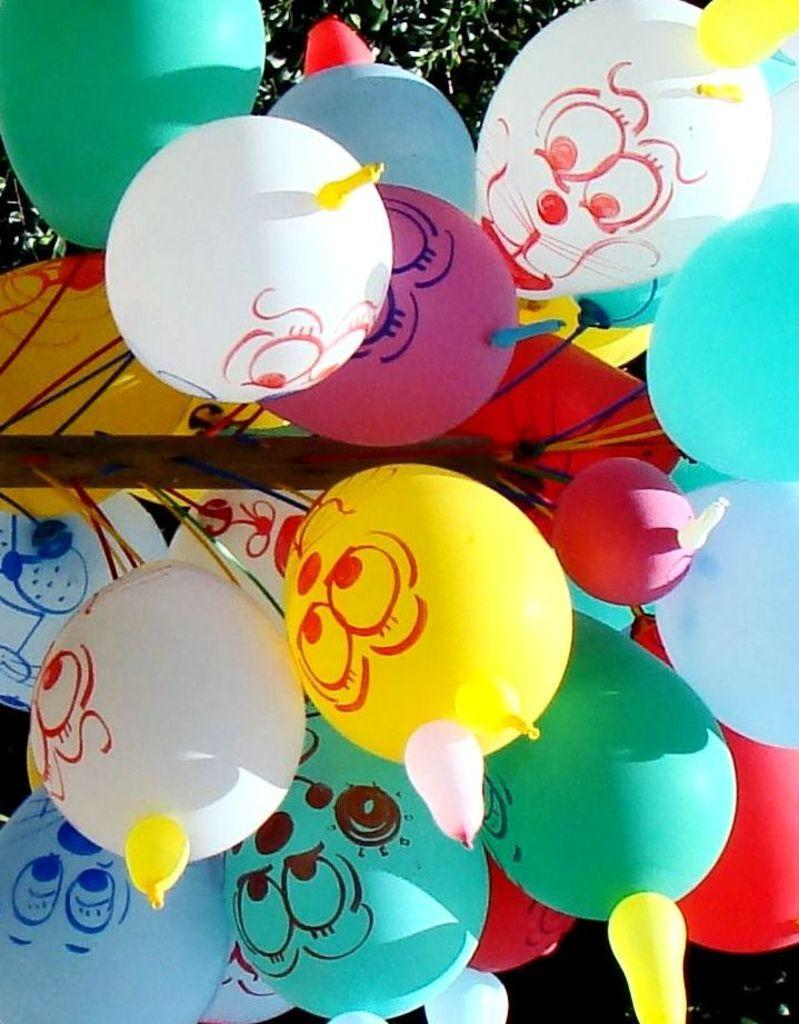What objects are present in the image? There are balloons in the image. Can you describe the appearance of the balloons? The balloons are colorful and may be of various shapes and sizes. Are the balloons floating or resting on a surface? The facts provided do not specify whether the balloons are floating or resting on a surface. What direction is the son heading in the image? There is no son present in the image; it only features balloons. 